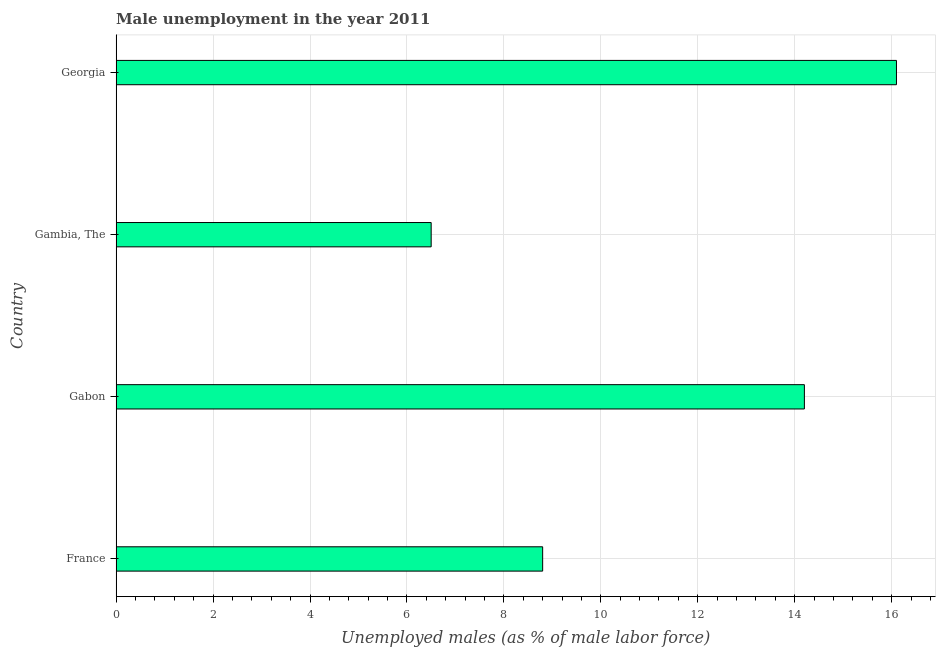Does the graph contain any zero values?
Give a very brief answer. No. What is the title of the graph?
Provide a succinct answer. Male unemployment in the year 2011. What is the label or title of the X-axis?
Your response must be concise. Unemployed males (as % of male labor force). What is the label or title of the Y-axis?
Provide a short and direct response. Country. What is the unemployed males population in Gabon?
Provide a short and direct response. 14.2. Across all countries, what is the maximum unemployed males population?
Give a very brief answer. 16.1. In which country was the unemployed males population maximum?
Your answer should be very brief. Georgia. In which country was the unemployed males population minimum?
Provide a short and direct response. Gambia, The. What is the sum of the unemployed males population?
Your answer should be very brief. 45.6. What is the difference between the unemployed males population in Gabon and Gambia, The?
Keep it short and to the point. 7.7. What is the average unemployed males population per country?
Give a very brief answer. 11.4. What is the median unemployed males population?
Provide a short and direct response. 11.5. What is the ratio of the unemployed males population in Gambia, The to that in Georgia?
Your answer should be compact. 0.4. Is the difference between the unemployed males population in Gabon and Gambia, The greater than the difference between any two countries?
Offer a very short reply. No. What is the difference between the highest and the second highest unemployed males population?
Your answer should be very brief. 1.9. What is the difference between the highest and the lowest unemployed males population?
Provide a short and direct response. 9.6. How many bars are there?
Your answer should be very brief. 4. What is the Unemployed males (as % of male labor force) in France?
Give a very brief answer. 8.8. What is the Unemployed males (as % of male labor force) in Gabon?
Your response must be concise. 14.2. What is the Unemployed males (as % of male labor force) in Gambia, The?
Your answer should be compact. 6.5. What is the Unemployed males (as % of male labor force) of Georgia?
Offer a very short reply. 16.1. What is the difference between the Unemployed males (as % of male labor force) in France and Gambia, The?
Make the answer very short. 2.3. What is the difference between the Unemployed males (as % of male labor force) in Gabon and Georgia?
Your answer should be compact. -1.9. What is the difference between the Unemployed males (as % of male labor force) in Gambia, The and Georgia?
Give a very brief answer. -9.6. What is the ratio of the Unemployed males (as % of male labor force) in France to that in Gabon?
Your response must be concise. 0.62. What is the ratio of the Unemployed males (as % of male labor force) in France to that in Gambia, The?
Offer a terse response. 1.35. What is the ratio of the Unemployed males (as % of male labor force) in France to that in Georgia?
Make the answer very short. 0.55. What is the ratio of the Unemployed males (as % of male labor force) in Gabon to that in Gambia, The?
Offer a terse response. 2.19. What is the ratio of the Unemployed males (as % of male labor force) in Gabon to that in Georgia?
Your response must be concise. 0.88. What is the ratio of the Unemployed males (as % of male labor force) in Gambia, The to that in Georgia?
Keep it short and to the point. 0.4. 